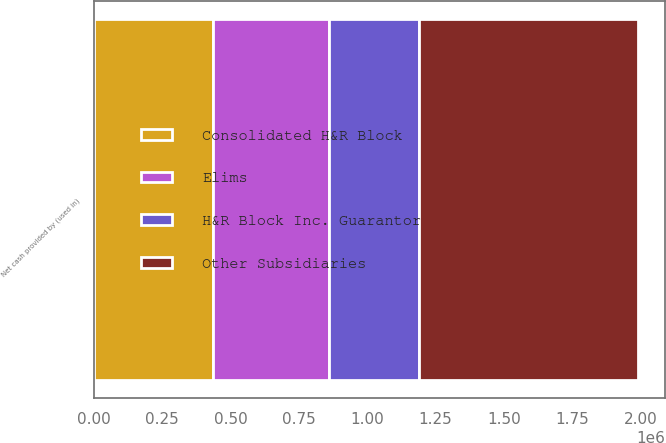<chart> <loc_0><loc_0><loc_500><loc_500><stacked_bar_chart><ecel><fcel>Net cash provided by (used in)<nl><fcel>Consolidated H&R Block<fcel>436843<nl><fcel>H&R Block Inc. Guarantor<fcel>332328<nl><fcel>Other Subsidiaries<fcel>798305<nl><fcel>Elims<fcel>421702<nl></chart> 